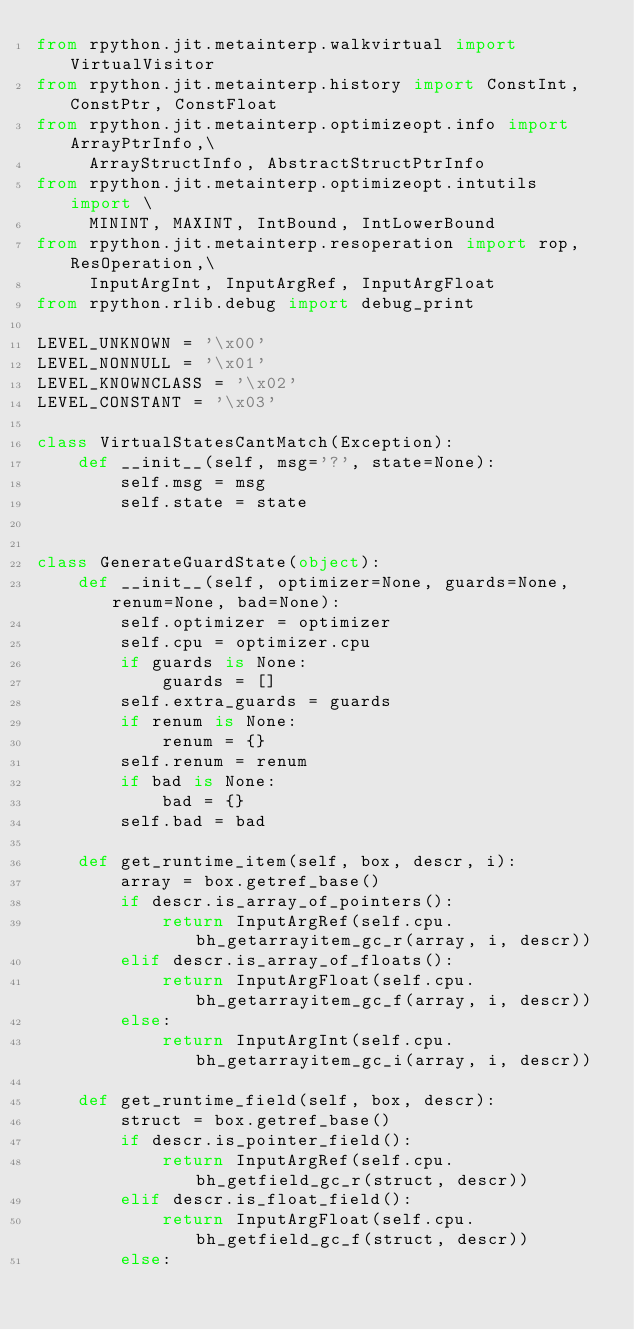Convert code to text. <code><loc_0><loc_0><loc_500><loc_500><_Python_>from rpython.jit.metainterp.walkvirtual import VirtualVisitor
from rpython.jit.metainterp.history import ConstInt, ConstPtr, ConstFloat
from rpython.jit.metainterp.optimizeopt.info import ArrayPtrInfo,\
     ArrayStructInfo, AbstractStructPtrInfo
from rpython.jit.metainterp.optimizeopt.intutils import \
     MININT, MAXINT, IntBound, IntLowerBound
from rpython.jit.metainterp.resoperation import rop, ResOperation,\
     InputArgInt, InputArgRef, InputArgFloat
from rpython.rlib.debug import debug_print

LEVEL_UNKNOWN = '\x00'
LEVEL_NONNULL = '\x01'
LEVEL_KNOWNCLASS = '\x02'
LEVEL_CONSTANT = '\x03'

class VirtualStatesCantMatch(Exception):
    def __init__(self, msg='?', state=None):
        self.msg = msg
        self.state = state


class GenerateGuardState(object):
    def __init__(self, optimizer=None, guards=None, renum=None, bad=None):
        self.optimizer = optimizer
        self.cpu = optimizer.cpu
        if guards is None:
            guards = []
        self.extra_guards = guards
        if renum is None:
            renum = {}
        self.renum = renum
        if bad is None:
            bad = {}
        self.bad = bad

    def get_runtime_item(self, box, descr, i):
        array = box.getref_base()
        if descr.is_array_of_pointers():
            return InputArgRef(self.cpu.bh_getarrayitem_gc_r(array, i, descr))
        elif descr.is_array_of_floats():
            return InputArgFloat(self.cpu.bh_getarrayitem_gc_f(array, i, descr))
        else:
            return InputArgInt(self.cpu.bh_getarrayitem_gc_i(array, i, descr))

    def get_runtime_field(self, box, descr):
        struct = box.getref_base()
        if descr.is_pointer_field():
            return InputArgRef(self.cpu.bh_getfield_gc_r(struct, descr))
        elif descr.is_float_field():
            return InputArgFloat(self.cpu.bh_getfield_gc_f(struct, descr))
        else:</code> 